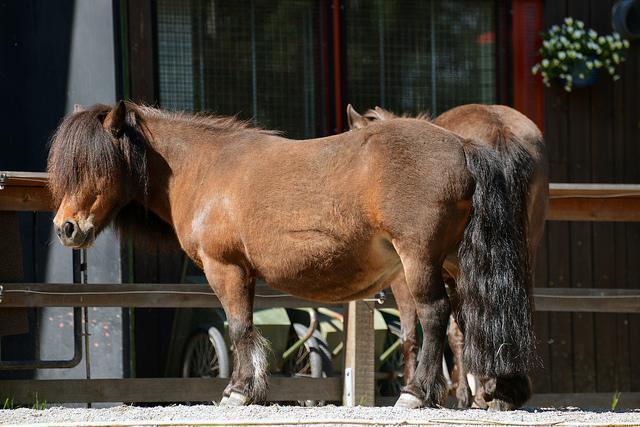What type of horse is this?
Indicate the correct response and explain using: 'Answer: answer
Rationale: rationale.'
Options: Arabian, shetland pony, clydesdale, mustang. Answer: shetland pony.
Rationale: A shetland pony is short and stocky with lots of mane and tail. 